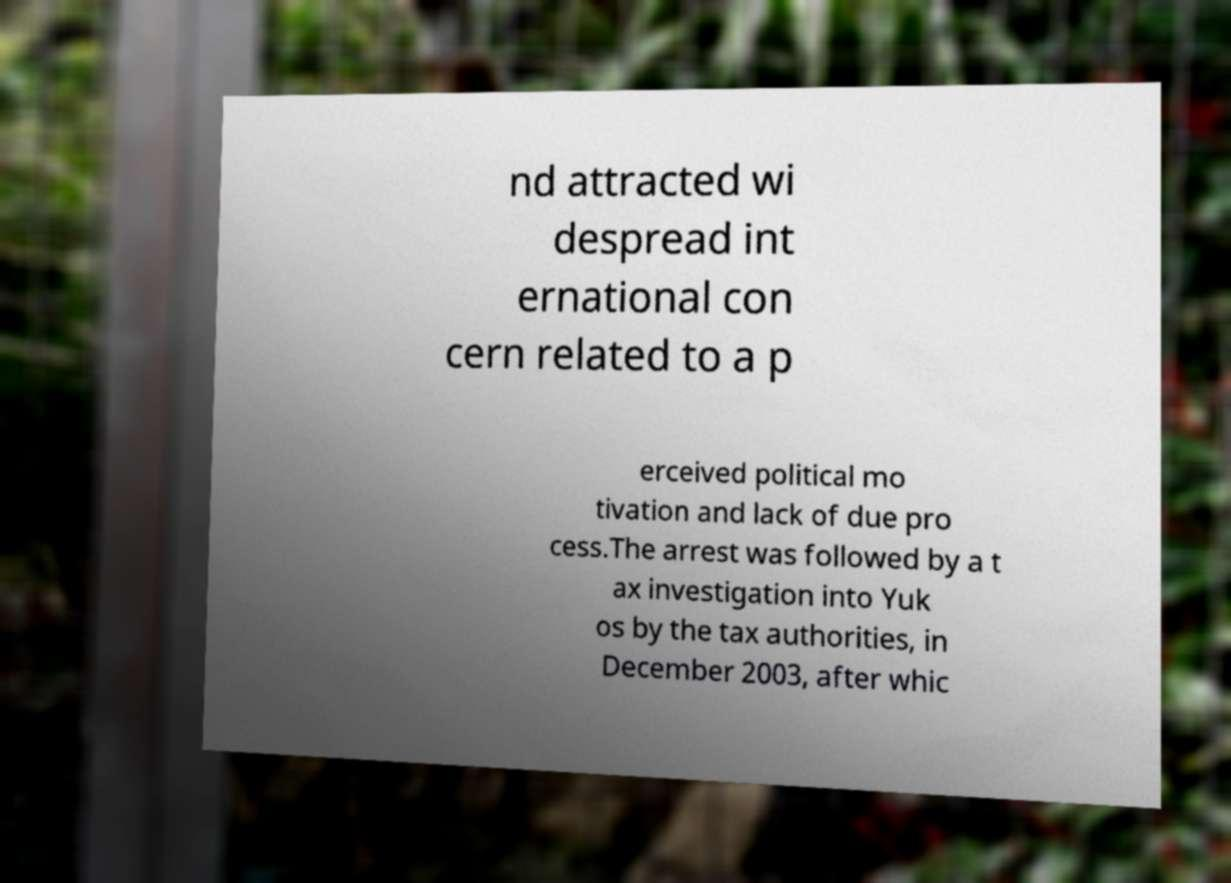I need the written content from this picture converted into text. Can you do that? nd attracted wi despread int ernational con cern related to a p erceived political mo tivation and lack of due pro cess.The arrest was followed by a t ax investigation into Yuk os by the tax authorities, in December 2003, after whic 